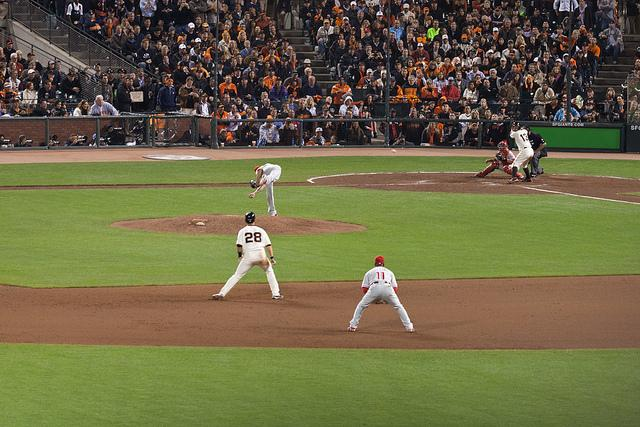Where does baseball come from? Please explain your reasoning. france. Baseball comes from france. 